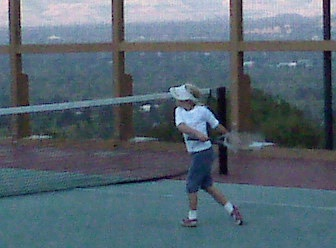Describe the objects in this image and their specific colors. I can see people in lightgray, gray, navy, and lightblue tones and tennis racket in lightgray, gray, black, and blue tones in this image. 